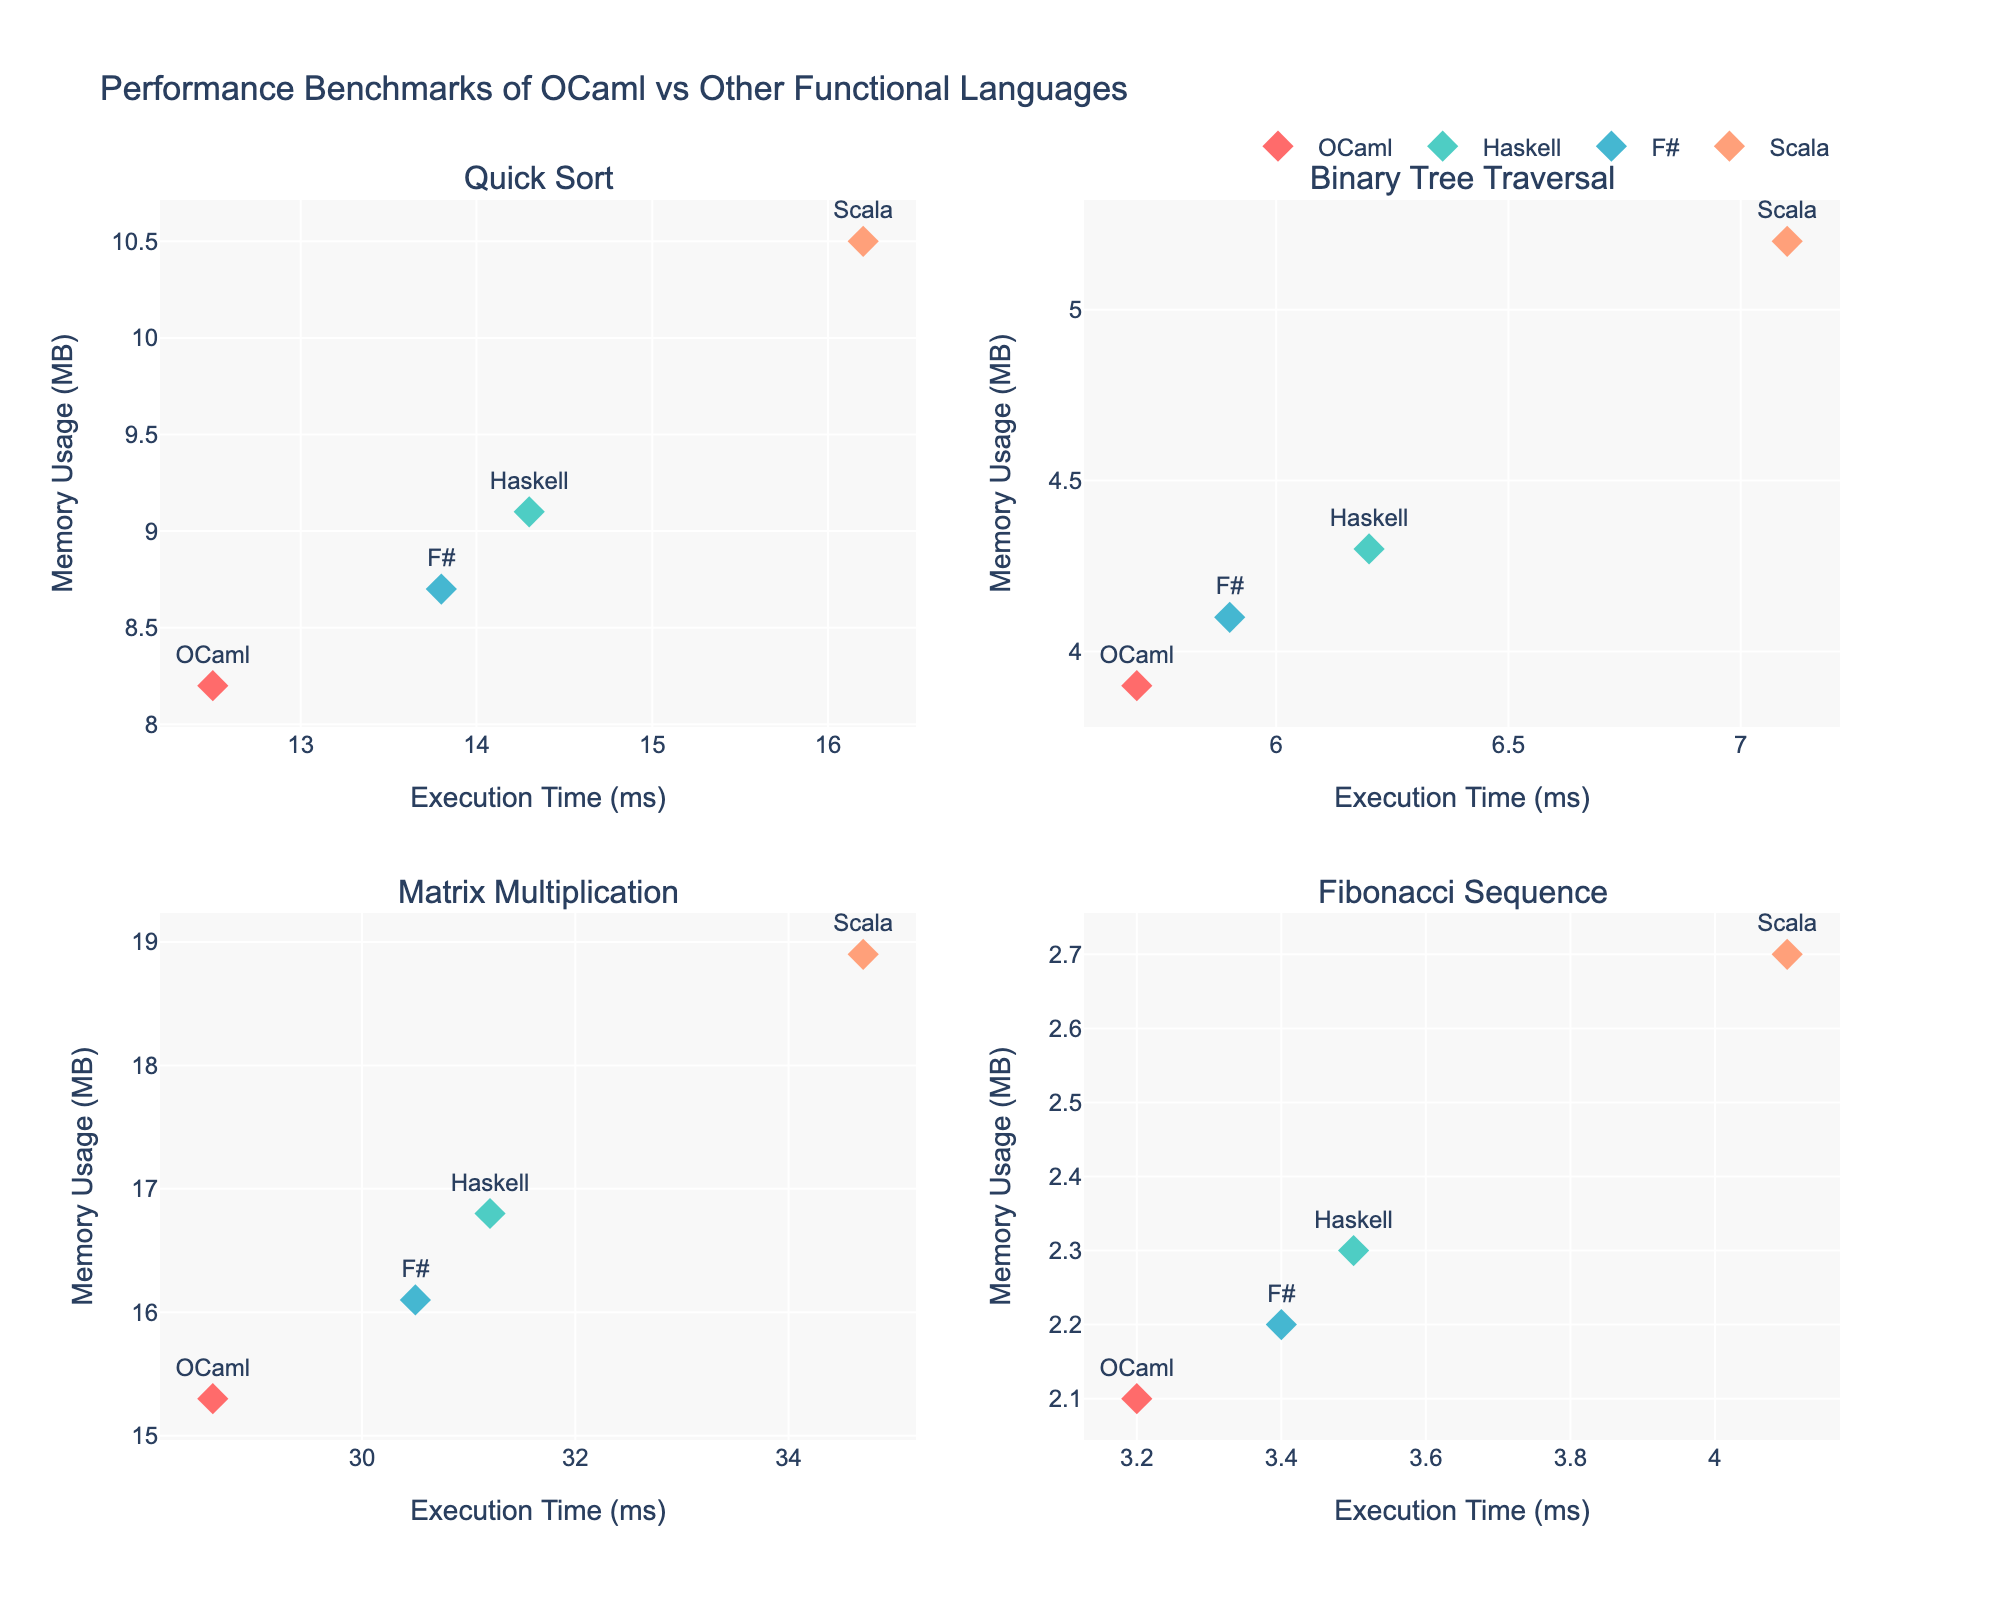How many subplots are there in total? There are 2 rows and 2 columns of subplots, making a total of 4 subplots.
Answer: 4 Which language has the fastest execution time for the Quick Sort task? In the Quick Sort subplot, OCaml shows the lowest execution time at approximately 12.5 ms.
Answer: OCaml What’s the difference in memory usage between OCaml and Scala for the Matrix Multiplication task? For Matrix Multiplication, OCaml uses 15.3 MB and Scala uses 18.9 MB. The difference is 18.9 - 15.3 = 3.6 MB.
Answer: 3.6 MB Which task shows the least variation in execution times among the four languages? By inspecting all subplots, Fibonacci Sequence has the least difference between the highest (Scala - 4.1 ms) and lowest (OCaml - 3.2 ms) execution times, 4.1 - 3.2 = 0.9 ms.
Answer: Fibonacci Sequence For the Binary Tree Traversal task, which language uses almost the same memory as OCaml? In the Binary Tree Traversal subplot, F# uses 4.1 MB, which is close to OCaml's 3.9 MB, with a difference of 0.2 MB.
Answer: F# How does the memory usage of Haskell for Matrix Multiplication compare to its memory usage for Quick Sort? Haskell uses 16.8 MB for Matrix Multiplication and 9.1 MB for Quick Sort. The difference is 16.8 - 9.1 = 7.7 MB.
Answer: 7.7 MB Is there any task where Scala is the best performer in both execution time and memory usage? For all the tasks, Scala has neither the lowest execution time nor the lowest memory usage compared to other languages.
Answer: No Which task has the largest difference in execution time between the best and worst-performing languages? Matrix Multiplication has the largest execution time range: Scala (34.7 ms) and OCaml (28.6 ms), yielding a difference of 34.7 - 28.6 = 6.1 ms.
Answer: Matrix Multiplication What is the average execution time across all tasks for OCaml? OCaml's execution times: 12.5 ms (Quick Sort), 5.7 ms (Binary Tree Traversal), 28.6 ms (Matrix Multiplication), and 3.2 ms (Fibonacci Sequence). Average = (12.5 + 5.7 + 28.6 + 3.2) / 4 = 12.5 ms.
Answer: 12.5 ms 